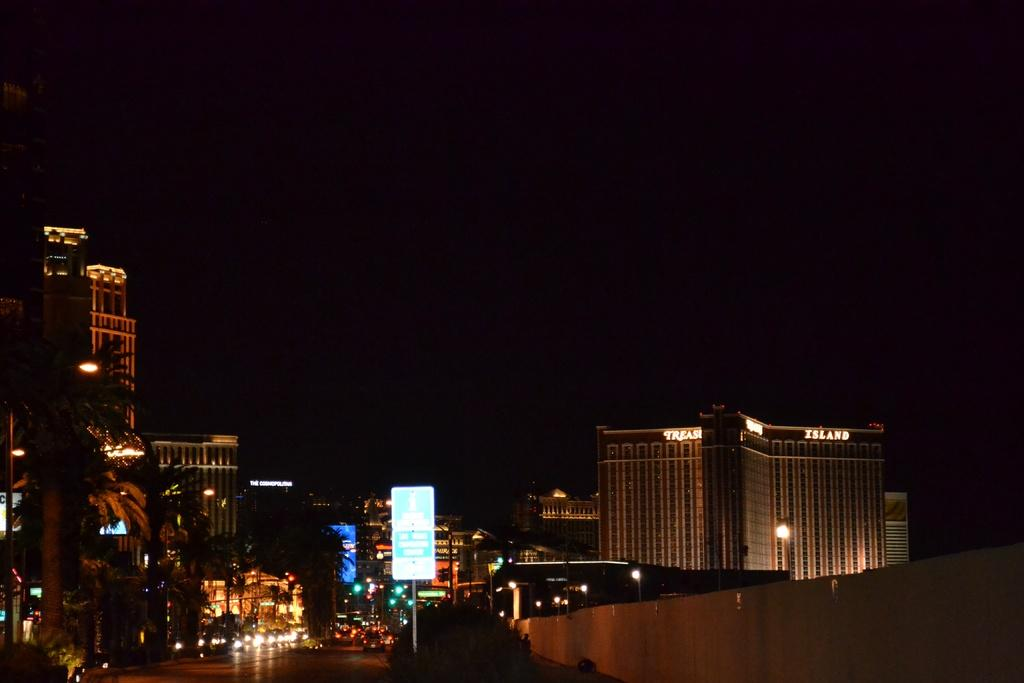What type of natural elements can be seen at the bottom of the image? There are trees at the bottom of the image. What man-made structures are present at the bottom of the image? There are sign boards, buildings, and vehicles at the bottom of the image. What type of powder can be seen falling from the sky in the image? There is no powder falling from the sky in the image. What causes the vehicles to stop in the image? The image does not show any vehicles stopping, nor does it provide information about why they might stop. 